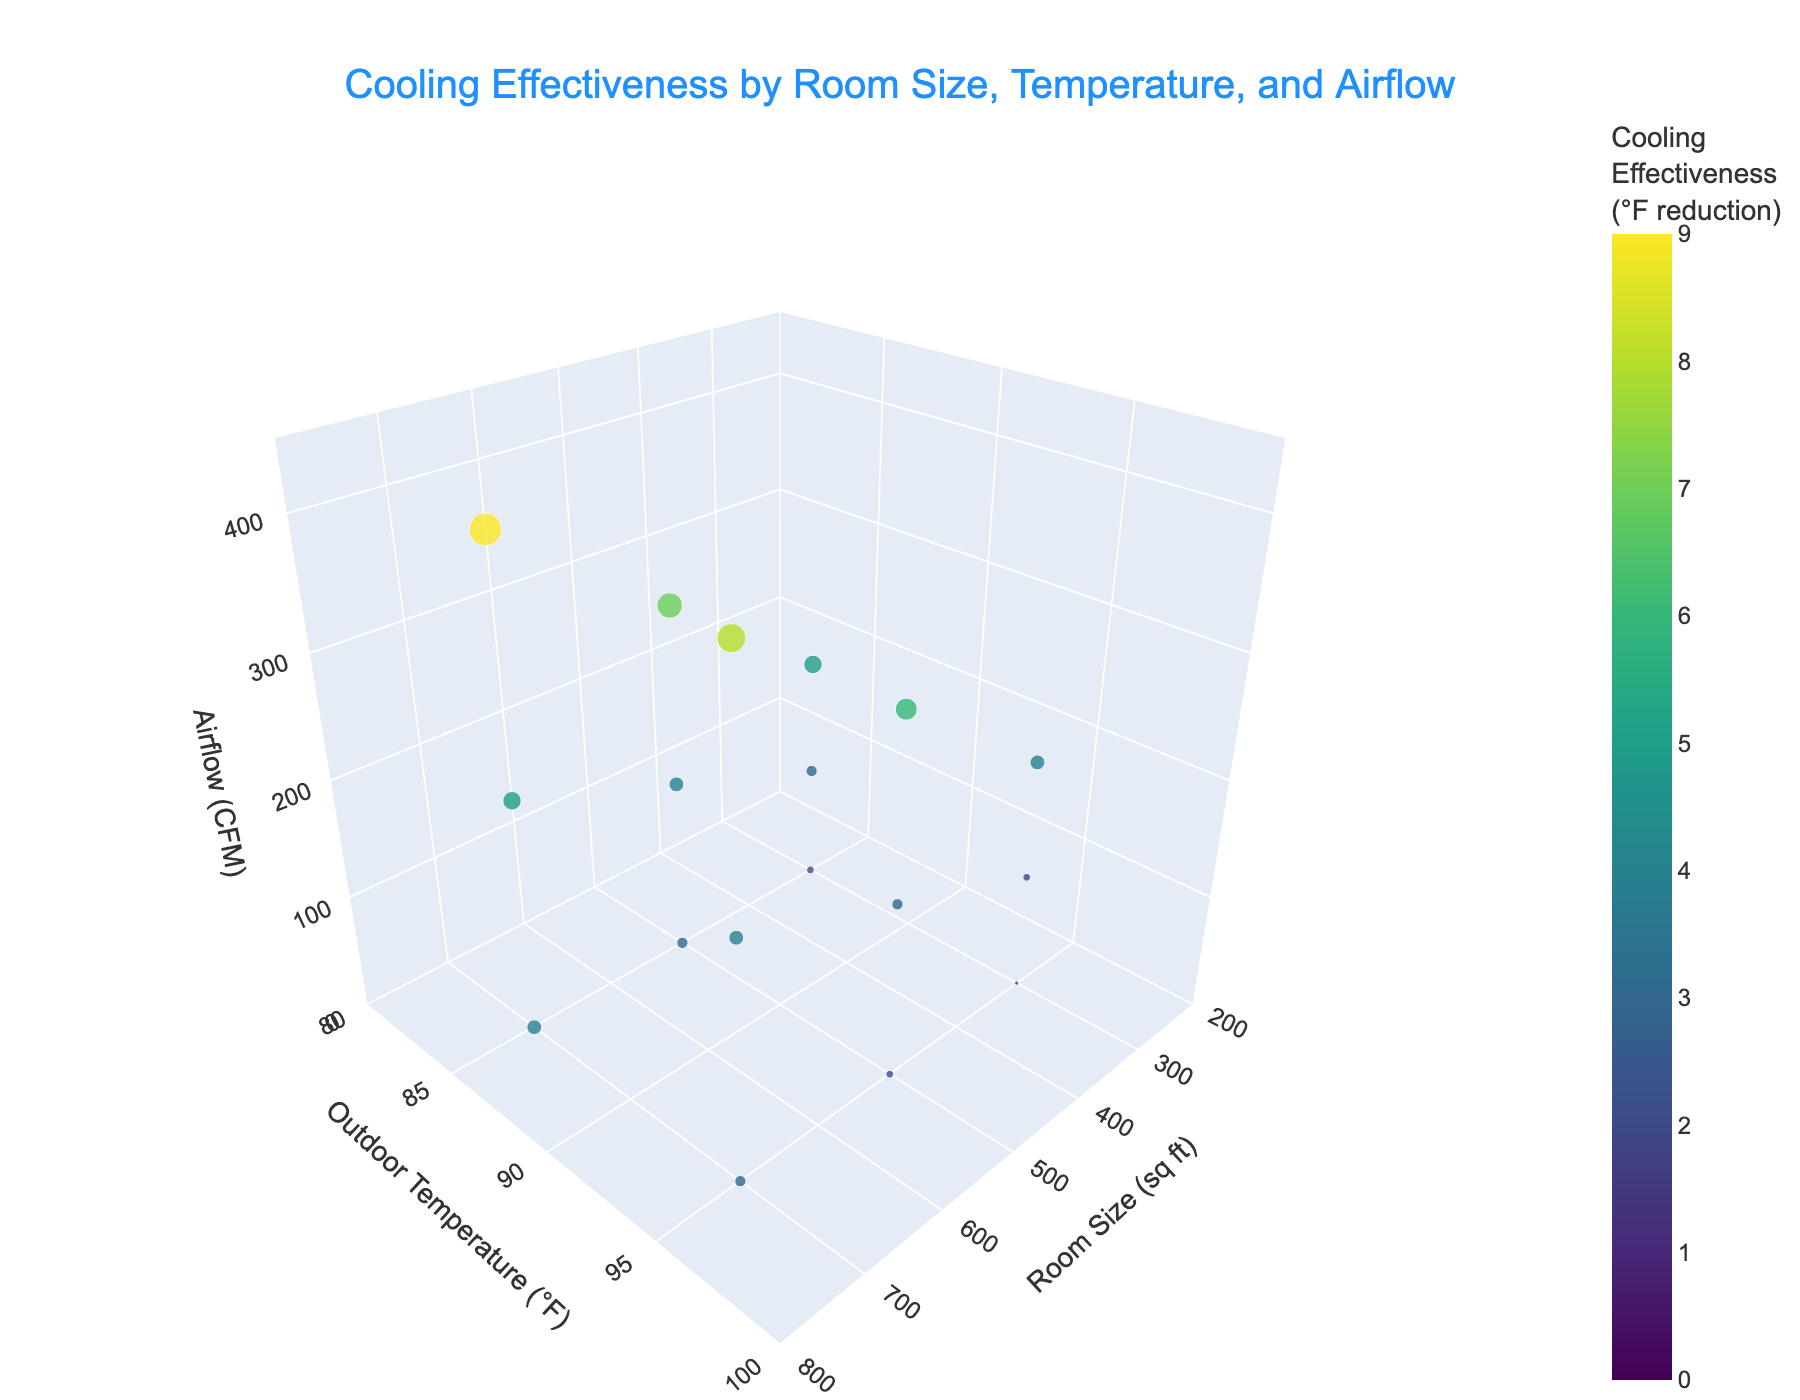What's the title of the figure? The title is prominently displayed at the top of the figure.
Answer: Cooling Effectiveness by Room Size, Temperature, and Airflow What does the color of the dots represent? The color of the dots in the plot represents the cooling effectiveness in terms of °F reduction, as indicated by the color bar on the right side of the figure.
Answer: Cooling Effectiveness (°F reduction) How does airflow affect cooling effectiveness? By observing the vertical axis (Airflow in CFM) and the color of the points, an increase in airflow generally results in higher cooling effectiveness, which is indicated by a shift to warmer colors.
Answer: Higher airflow generally increases cooling effectiveness Which room size has the highest cooling effectiveness at an outdoor temperature of 95°F? Comparing points on the y-axis at 95°F, the room size of 700 sq ft has the highest cooling effectiveness, represented by the point with the warmest color and a larger marker size.
Answer: 700 sq ft What is the range of room sizes displayed on the x-axis? The room sizes on the x-axis range from 200 to 800 sq ft, as indicated by the axis labels.
Answer: 200 to 800 sq ft For a room size of 500 sq ft and minimum airflow, what is the approximate cooling effectiveness when the outdoor temperature is 85°F? By finding the point where the room size is 500 sq ft and airflow is minimum (0 CFM) at 85°F, the cooling effectiveness can be seen. The marker’s color and size indicate an effectiveness of around 3°F reduction.
Answer: Approximately 3°F reduction How does outdoor temperature impact cooling effectiveness across all room sizes? Observing all points along the y-axis for different temperatures, higher outdoor temperatures generally result in lower cooling effectiveness, as indicated by the cooler colors.
Answer: Higher outdoor temperatures generally reduce cooling effectiveness Which airflow rate shows the most significant difference in cooling effectiveness, and for which room size? By examining the change in cooling effectiveness across different airflow rates (CFM), the room size of 700 sq ft shows the most significant difference, with effectiveness improving from 4°F reduction at 0 CFM to 9°F at 400 CFM when the temperature is 85°F.
Answer: 700 sq ft What are the minimum and maximum values for cooling effectiveness displayed in the plot? From the color bar and the dot sizes, the minimum cooling effectiveness is 0°F reduction (coolest color, smallest marker), and the maximum is 9°F reduction (warmest color, largest marker).
Answer: 0°F to 9°F 